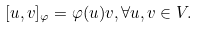Convert formula to latex. <formula><loc_0><loc_0><loc_500><loc_500>[ u , v ] _ { \varphi } = \varphi ( u ) v , \forall u , v \in V .</formula> 